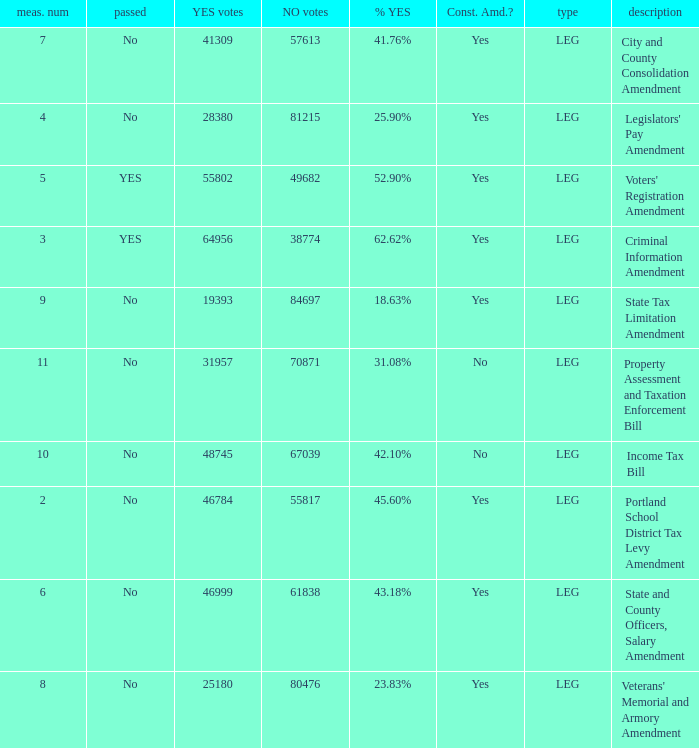HOw many no votes were there when there were 45.60% yes votes 55817.0. 